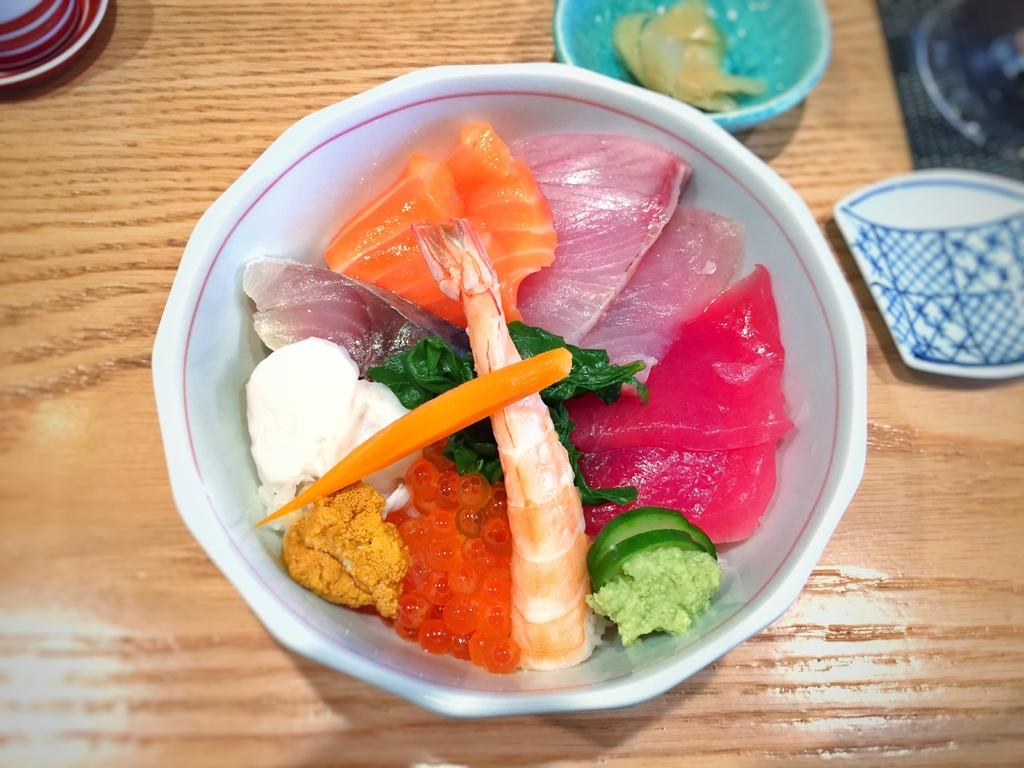What type of containers are holding food items in the image? There are bowls holding food items in the image. What else can be seen on the wooden board in the image? There are objects on the wooden board in the image. Where is the kettle located in the image? There is no kettle present in the image. What type of branch is holding the food items in the image? There is no branch holding the food items in the image; they are in bowls. 